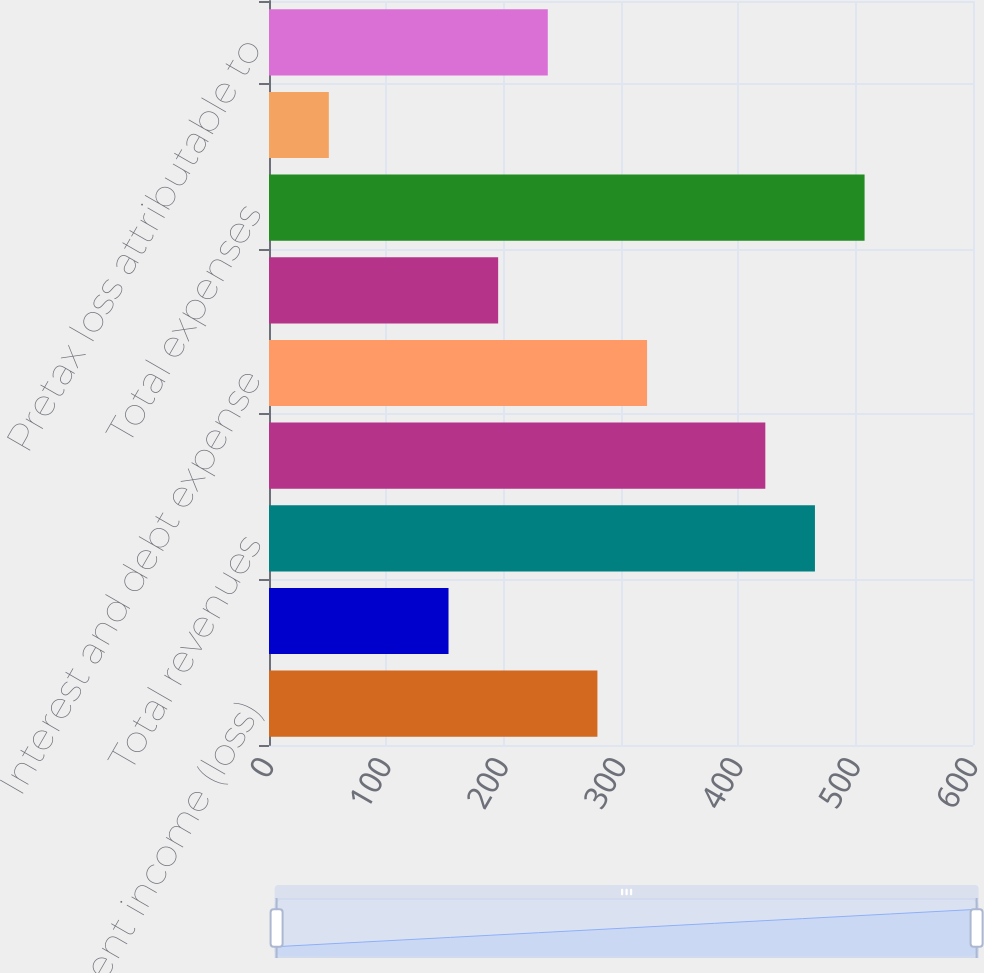<chart> <loc_0><loc_0><loc_500><loc_500><bar_chart><fcel>Net investment income (loss)<fcel>Other revenues<fcel>Total revenues<fcel>Total net revenues<fcel>Interest and debt expense<fcel>General and administrative<fcel>Total expenses<fcel>Pretax loss<fcel>Pretax loss attributable to<nl><fcel>279.9<fcel>153<fcel>465.3<fcel>423<fcel>322.2<fcel>195.3<fcel>507.6<fcel>51<fcel>237.6<nl></chart> 